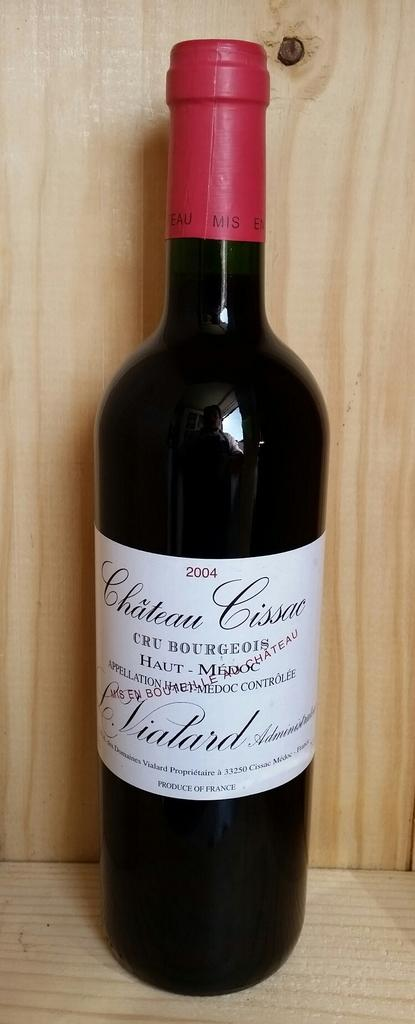<image>
Relay a brief, clear account of the picture shown. A bottle of a 2004 Chateau Cissac was produced in France. 